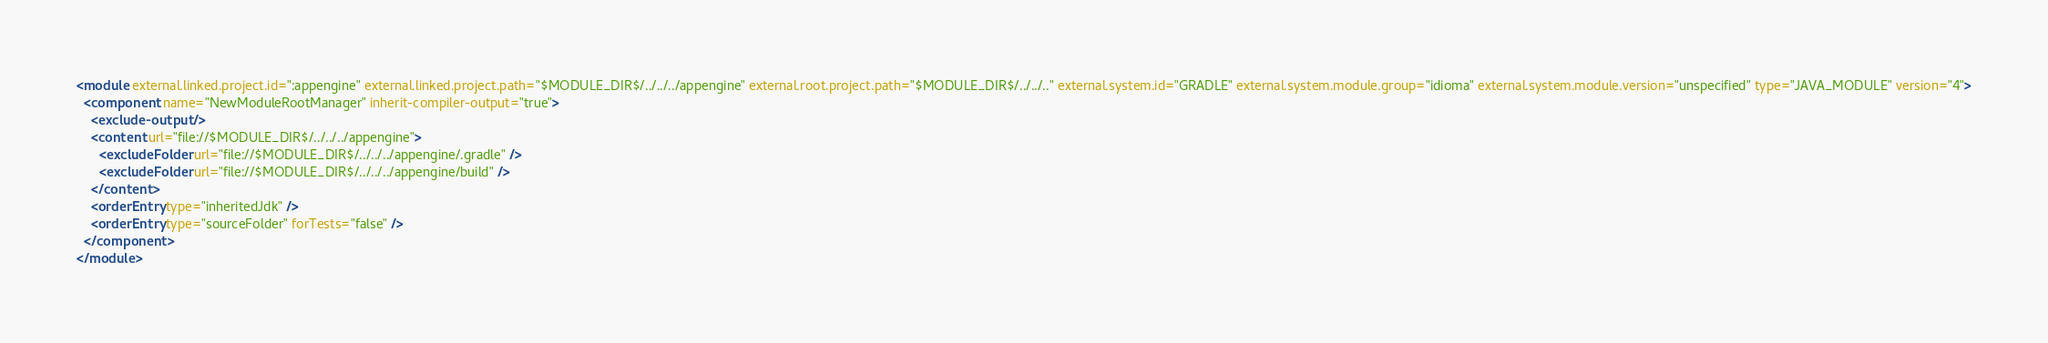Convert code to text. <code><loc_0><loc_0><loc_500><loc_500><_XML_><module external.linked.project.id=":appengine" external.linked.project.path="$MODULE_DIR$/../../../appengine" external.root.project.path="$MODULE_DIR$/../../.." external.system.id="GRADLE" external.system.module.group="idioma" external.system.module.version="unspecified" type="JAVA_MODULE" version="4">
  <component name="NewModuleRootManager" inherit-compiler-output="true">
    <exclude-output />
    <content url="file://$MODULE_DIR$/../../../appengine">
      <excludeFolder url="file://$MODULE_DIR$/../../../appengine/.gradle" />
      <excludeFolder url="file://$MODULE_DIR$/../../../appengine/build" />
    </content>
    <orderEntry type="inheritedJdk" />
    <orderEntry type="sourceFolder" forTests="false" />
  </component>
</module></code> 